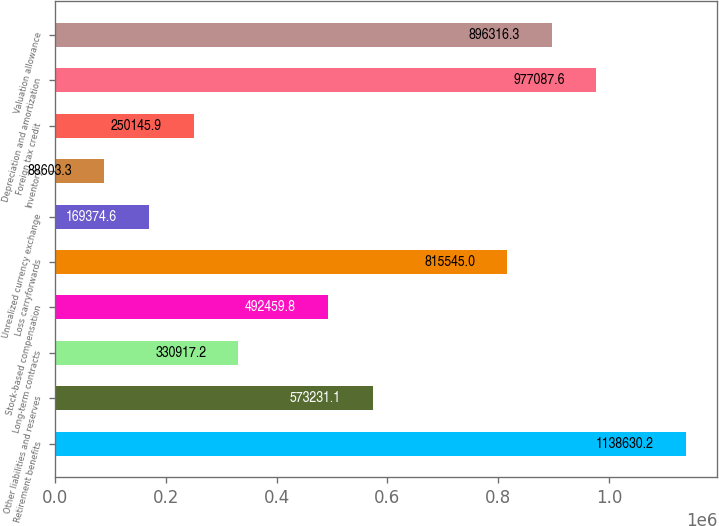Convert chart to OTSL. <chart><loc_0><loc_0><loc_500><loc_500><bar_chart><fcel>Retirement benefits<fcel>Other liabilities and reserves<fcel>Long-term contracts<fcel>Stock-based compensation<fcel>Loss carryforwards<fcel>Unrealized currency exchange<fcel>Inventory<fcel>Foreign tax credit<fcel>Depreciation and amortization<fcel>Valuation allowance<nl><fcel>1.13863e+06<fcel>573231<fcel>330917<fcel>492460<fcel>815545<fcel>169375<fcel>88603.3<fcel>250146<fcel>977088<fcel>896316<nl></chart> 